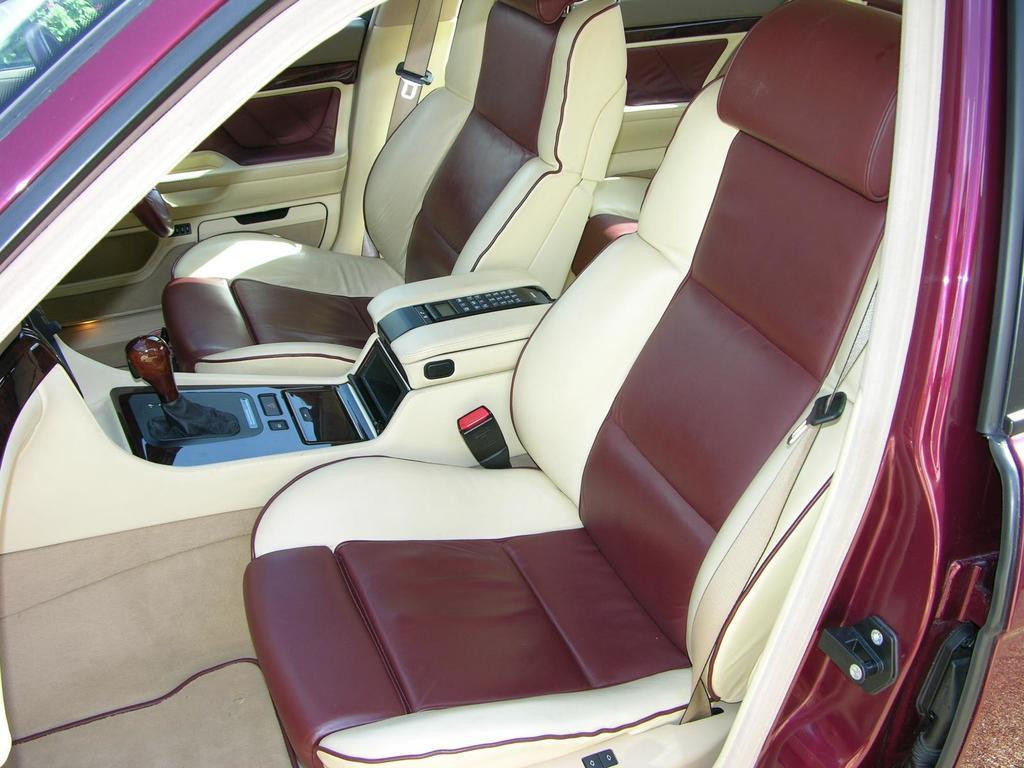How would you summarize this image in a sentence or two? In this image we can see an inner view of a car containing some seats, gear and the steering. 